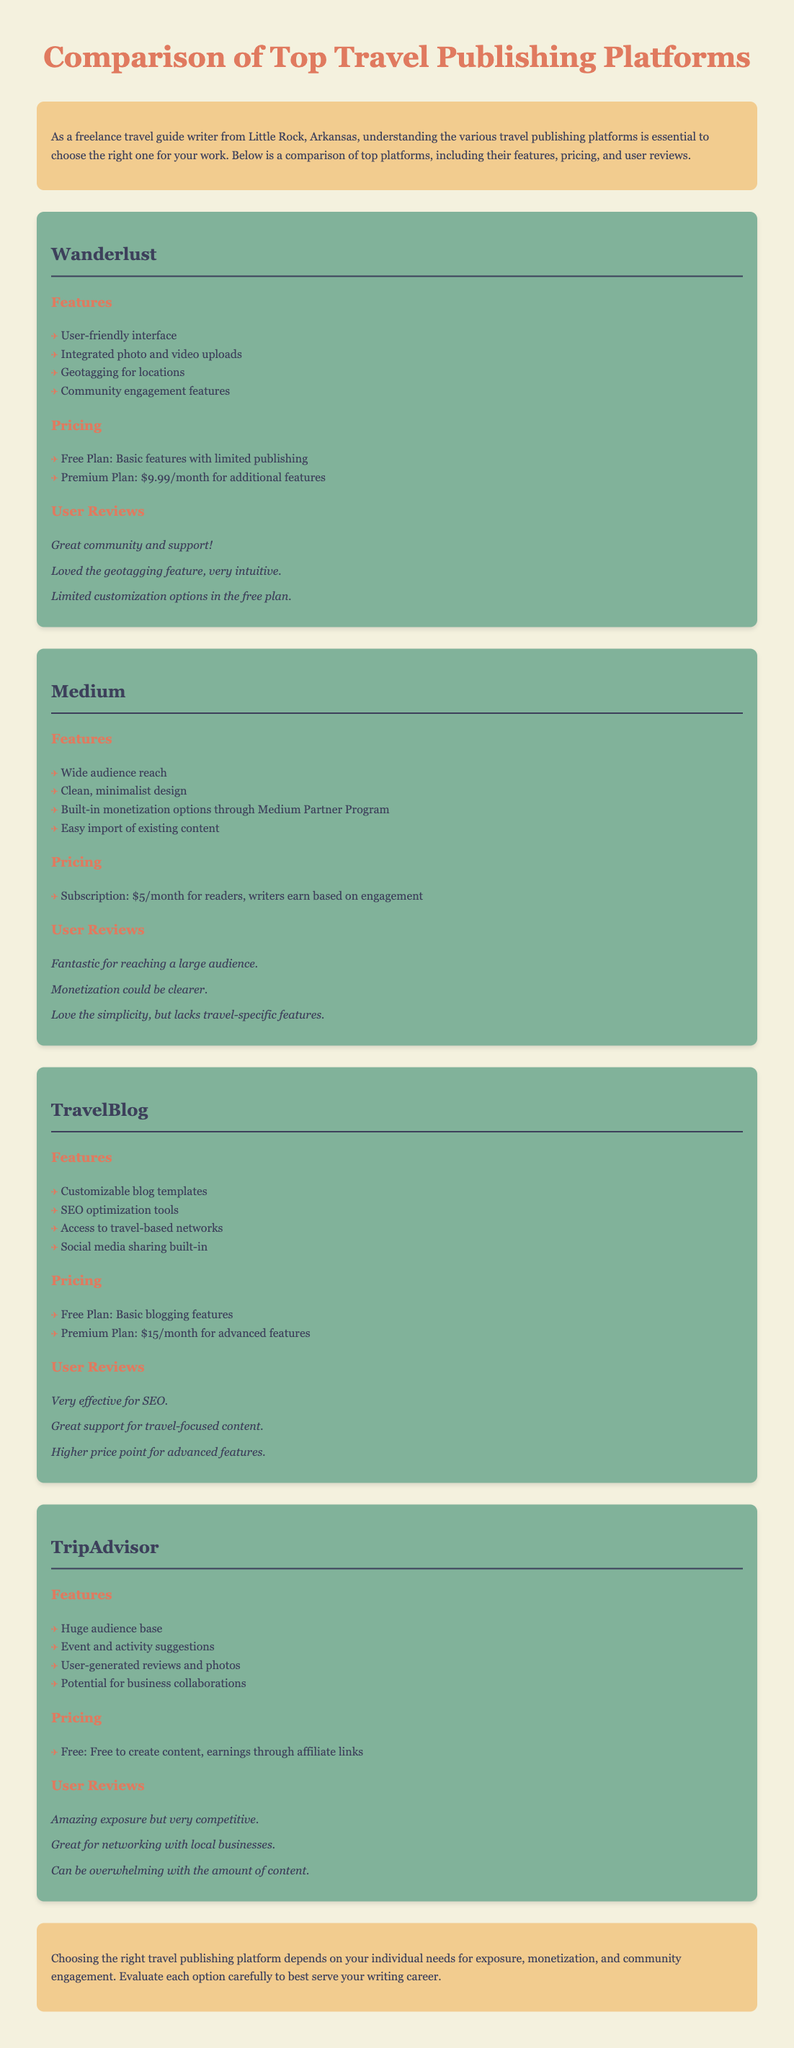What is the name of the first platform mentioned? The first platform listed in the document is Wanderlust.
Answer: Wanderlust How much is the Premium Plan for Wanderlust? The Premium Plan for Wanderlust is priced at $9.99 per month.
Answer: $9.99/month What feature is highlighted in Medium regarding monetization? Medium has built-in monetization options through the Medium Partner Program.
Answer: Medium Partner Program Which platform offers a free plan for basic blogging features? TravelBlog offers a free plan that includes basic blogging features.
Answer: TravelBlog What is the main advantage of TripAdvisor mentioned in user reviews? Users mention amazing exposure as an advantage of using TripAdvisor.
Answer: Amazing exposure Which platform has a monthly subscription fee of $5 for readers? Medium requires a subscription of $5/month for its readers.
Answer: $5/month What unique feature does TravelBlog provide for SEO? TravelBlog offers SEO optimization tools as a unique feature.
Answer: SEO optimization tools What is a common complaint about the Limited Plan of Wanderlust? A common complaint is limited customization options in the free plan.
Answer: Limited customization options What is included in the pricing for TripAdvisor? TripAdvisor is free to create content, with earnings through affiliate links.
Answer: Free 